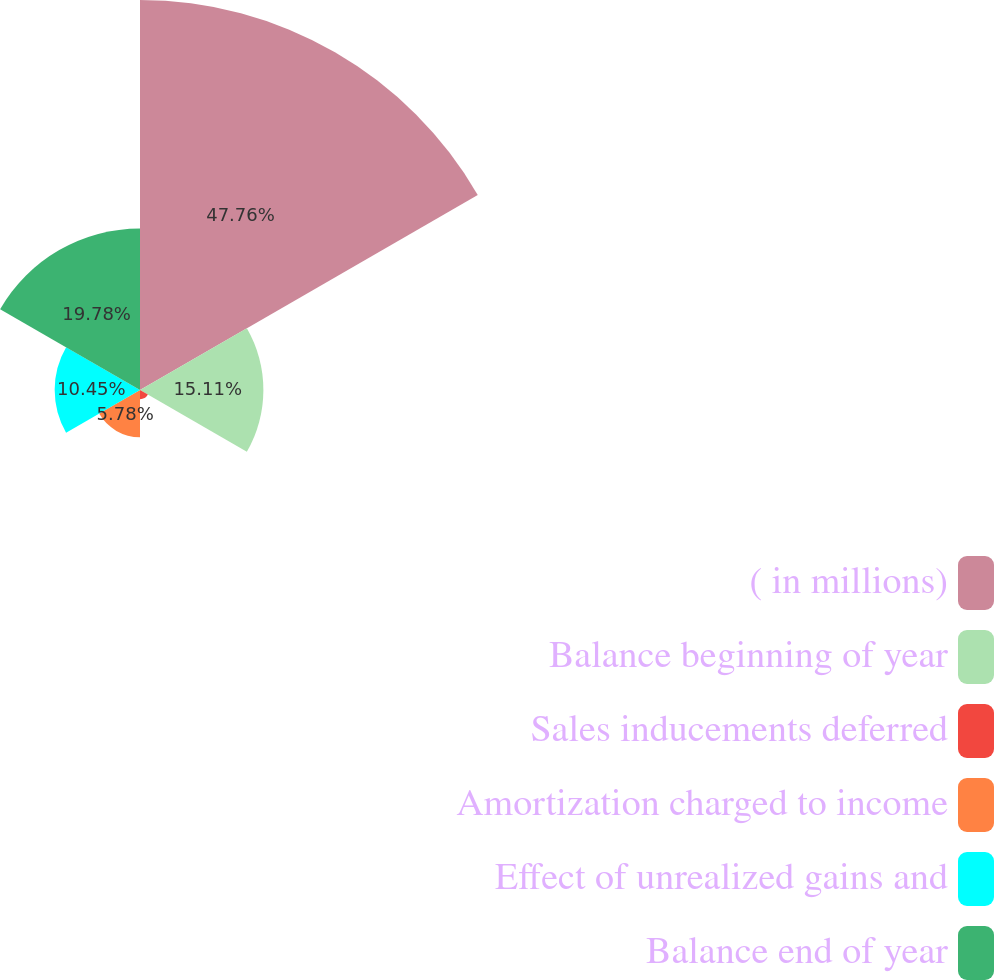Convert chart. <chart><loc_0><loc_0><loc_500><loc_500><pie_chart><fcel>( in millions)<fcel>Balance beginning of year<fcel>Sales inducements deferred<fcel>Amortization charged to income<fcel>Effect of unrealized gains and<fcel>Balance end of year<nl><fcel>47.76%<fcel>15.11%<fcel>1.12%<fcel>5.78%<fcel>10.45%<fcel>19.78%<nl></chart> 